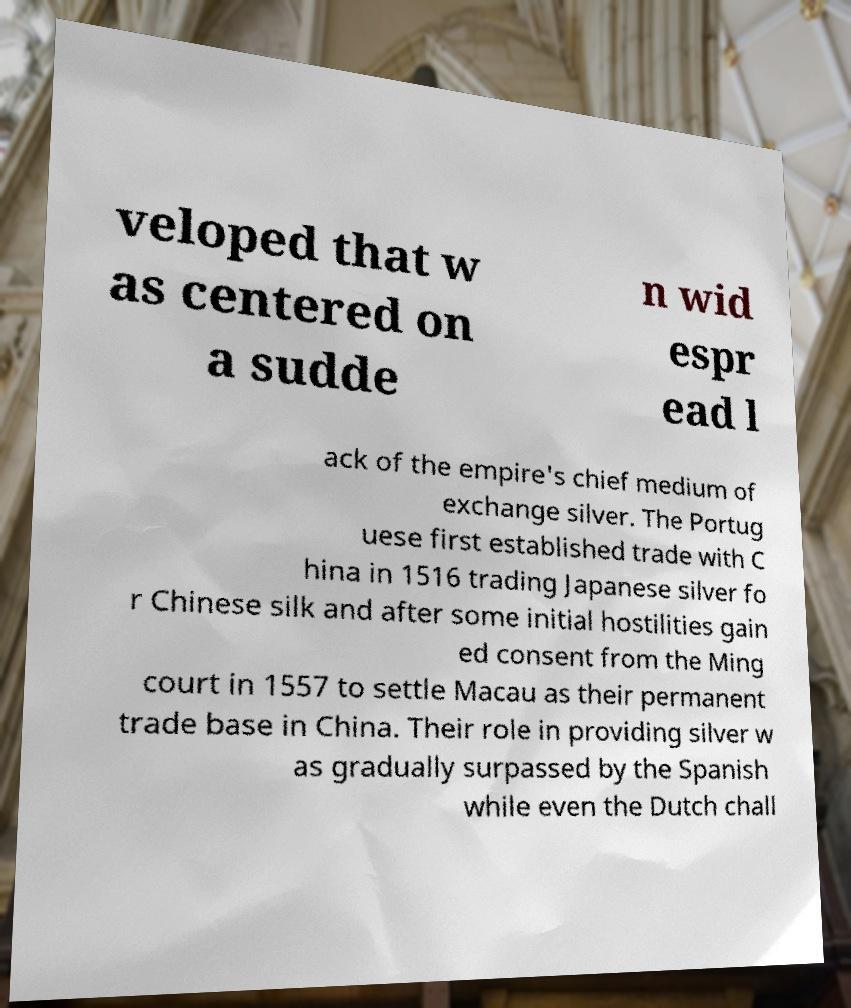Can you accurately transcribe the text from the provided image for me? veloped that w as centered on a sudde n wid espr ead l ack of the empire's chief medium of exchange silver. The Portug uese first established trade with C hina in 1516 trading Japanese silver fo r Chinese silk and after some initial hostilities gain ed consent from the Ming court in 1557 to settle Macau as their permanent trade base in China. Their role in providing silver w as gradually surpassed by the Spanish while even the Dutch chall 